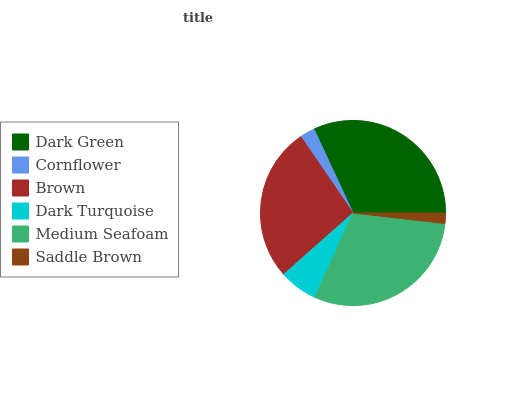Is Saddle Brown the minimum?
Answer yes or no. Yes. Is Dark Green the maximum?
Answer yes or no. Yes. Is Cornflower the minimum?
Answer yes or no. No. Is Cornflower the maximum?
Answer yes or no. No. Is Dark Green greater than Cornflower?
Answer yes or no. Yes. Is Cornflower less than Dark Green?
Answer yes or no. Yes. Is Cornflower greater than Dark Green?
Answer yes or no. No. Is Dark Green less than Cornflower?
Answer yes or no. No. Is Brown the high median?
Answer yes or no. Yes. Is Dark Turquoise the low median?
Answer yes or no. Yes. Is Medium Seafoam the high median?
Answer yes or no. No. Is Medium Seafoam the low median?
Answer yes or no. No. 